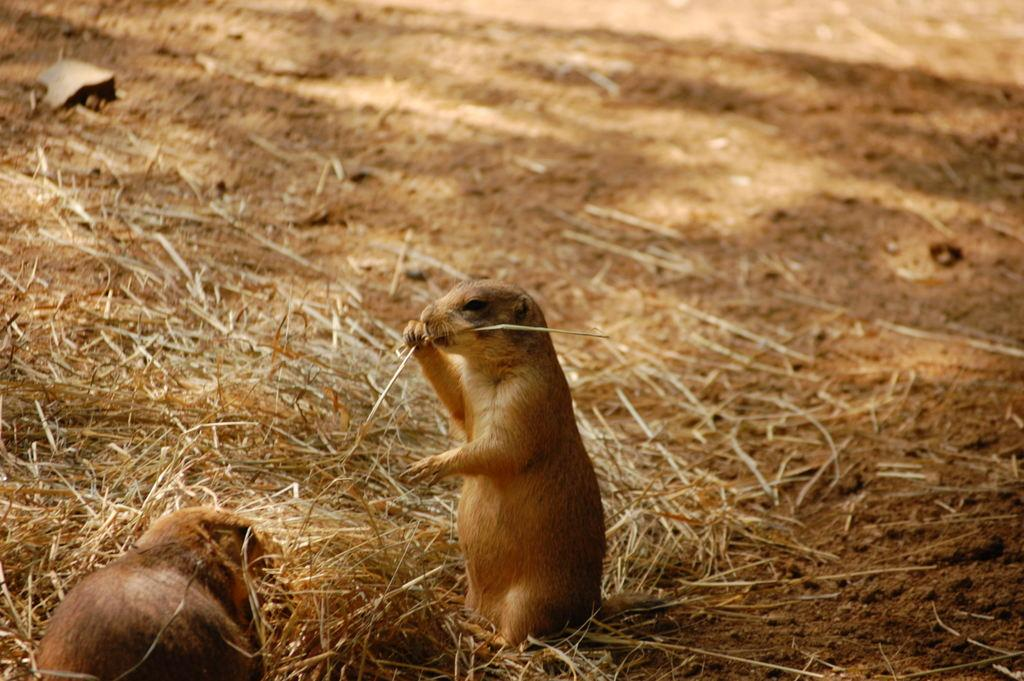How many squirrels are present in the image? There are two squirrels in the image. What is the position of one of the squirrels in the image? One squirrel is standing in the center of the image. What is the squirrel in the center doing? The squirrel in the center is eating grass. What type of vegetation can be seen on the ground in the image? There is dried grass on the ground in the image. What decision did the squirrels make about their relationship in the image? There is no indication of a relationship between the squirrels in the image, nor any decision-making process. 